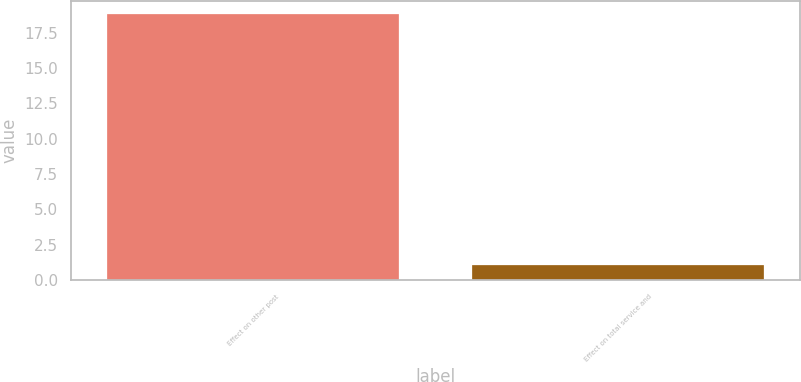Convert chart. <chart><loc_0><loc_0><loc_500><loc_500><bar_chart><fcel>Effect on other post<fcel>Effect on total service and<nl><fcel>18.8<fcel>1.1<nl></chart> 